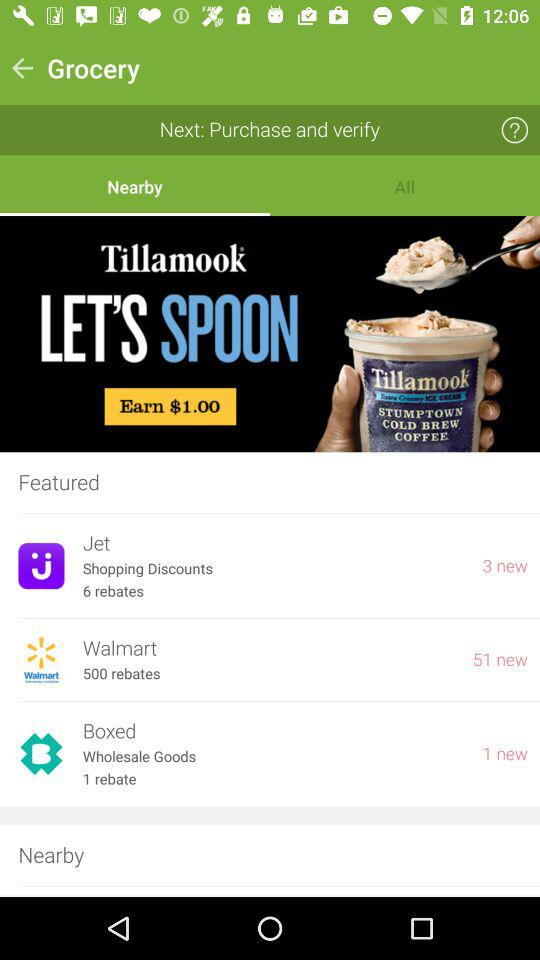Which stores are nearby?
When the provided information is insufficient, respond with <no answer>. <no answer> 